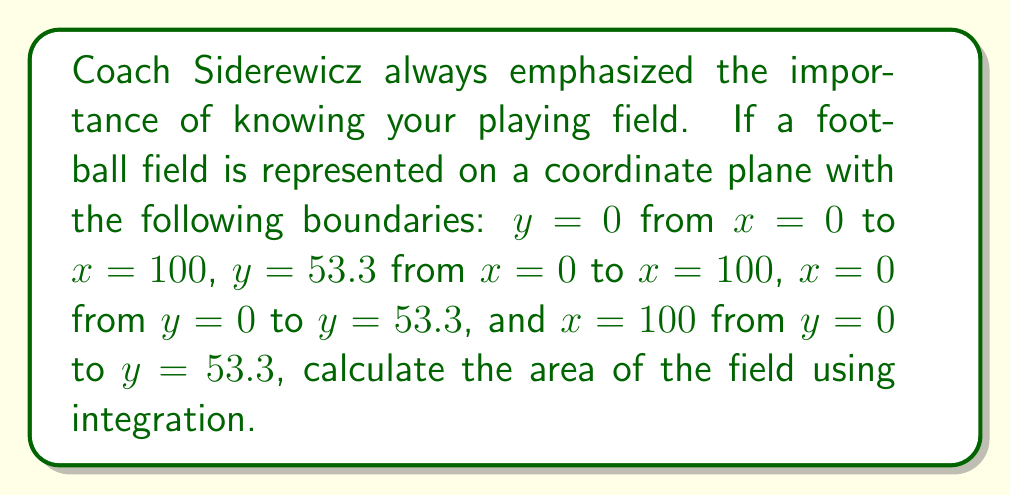Help me with this question. Let's approach this step-by-step:

1) The football field is essentially a rectangle on the coordinate plane. We can find its area by integrating the width of the field with respect to its length.

2) The width of the field is constant at 53.3 yards, and the length goes from 0 to 100 yards.

3) We can set up our integral as follows:

   $$A = \int_{0}^{100} 53.3 \, dx$$

4) Since 53.3 is a constant, we can take it outside the integral:

   $$A = 53.3 \int_{0}^{100} 1 \, dx$$

5) Integrating:

   $$A = 53.3 [x]_{0}^{100}$$

6) Evaluating the integral:

   $$A = 53.3 (100 - 0) = 53.3 \cdot 100$$

7) Calculating the final result:

   $$A = 5330 \text{ square yards}$$

This matches the standard dimensions of a football field: 100 yards long and 53.3 yards wide.
Answer: 5330 square yards 